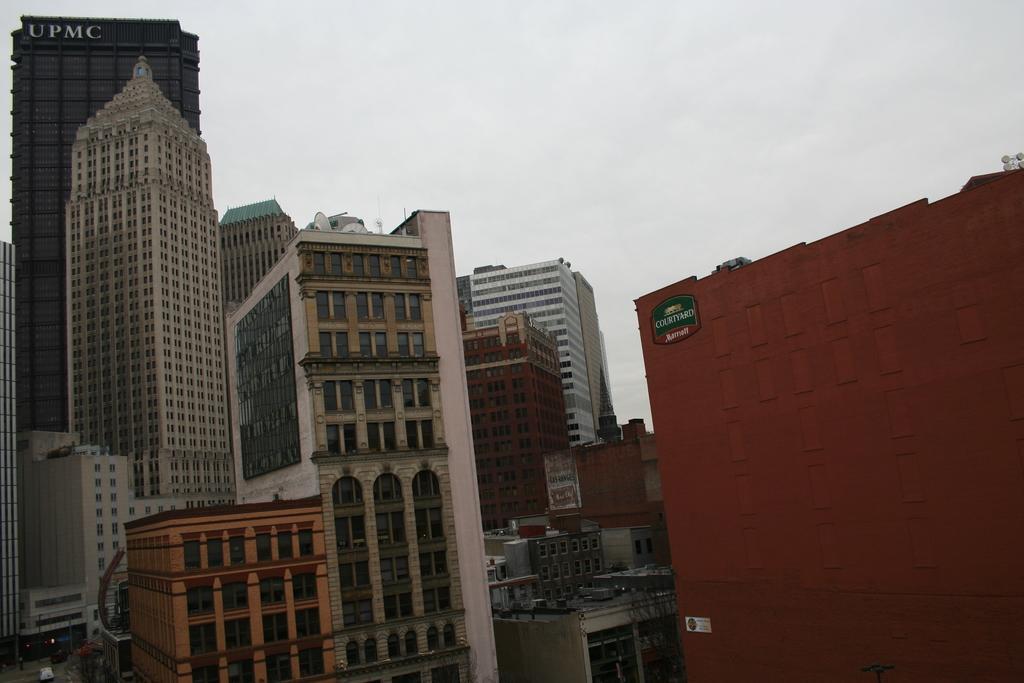How would you summarize this image in a sentence or two? In this image we can see buildings. In the background there is sky. 